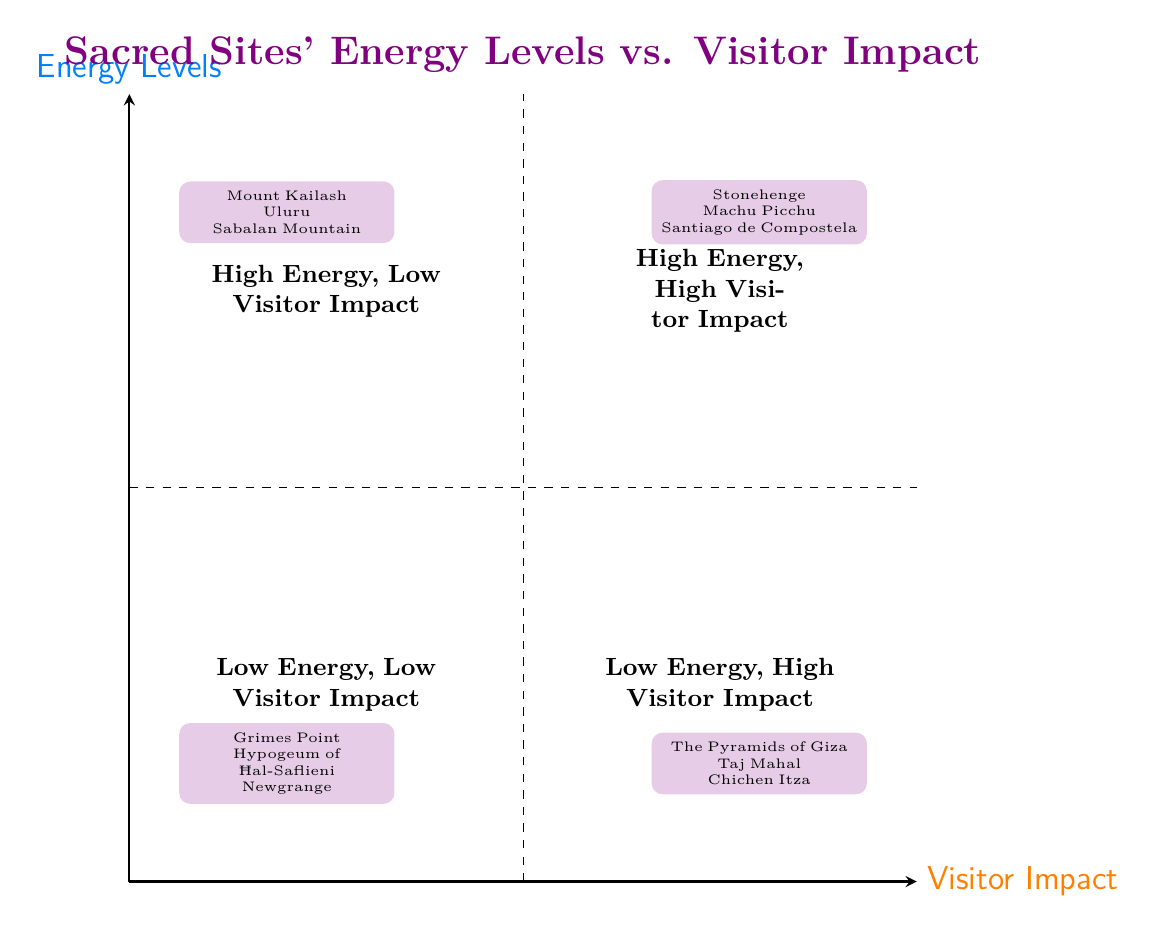What are the examples in the "High Energy, Low Visitor Impact" quadrant? The "High Energy, Low Visitor Impact" quadrant includes three sites: Mount Kailash, Uluru, and Sabalan Mountain. These are listed within the quadrant area in the diagram.
Answer: Mount Kailash, Uluru, Sabalan Mountain How many quadrants are displayed in the diagram? There are four quadrants shown in the diagram, which are divided based on energy levels and visitor impact.
Answer: 4 Which quadrant contains Stonehenge? Stonehenge is located in the "High Energy, High Visitor Impact" quadrant, as specified in the examples listed in that area.
Answer: High Energy, High Visitor Impact What site is associated with "Low Energy, High Visitor Impact"? The site associated with "Low Energy, High Visitor Impact" in the diagram is the Pyramids of Giza, as mentioned clearly under that quadrant.
Answer: The Pyramids of Giza Is there any site listed in the "Low Energy, Low Visitor Impact" quadrant? Yes, there are examples such as Grimes Point, Hypogeum of Ħal-Saflieni, and Newgrange mentioned in the "Low Energy, Low Visitor Impact" quadrant.
Answer: Yes Why might sacred sites with high energy levels be important for visitors? Sacred sites with high energy levels may offer profound spiritual experiences, attract those seeking enlightenment, and enable deeper meditation practices, highlighting their significance beyond mere visitation numbers.
Answer: Spiritual experiences In which quadrant would you find Machu Picchu? Machu Picchu appears in the "High Energy, High Visitor Impact" quadrant, as indicated by the examples provided within that area.
Answer: High Energy, High Visitor Impact What can be inferred about visitor impact and energy levels in the context of these sites? There is a relationship where sites with high energy often have increased visitor impacts, while lower energy sites tend to attract fewer visitors, illustrating the concurrent nature of spiritual significance and tourism.
Answer: Relationship exists 